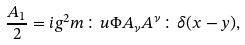<formula> <loc_0><loc_0><loc_500><loc_500>\frac { A _ { 1 } } { 2 } = i g ^ { 2 } m \colon u \Phi A _ { \nu } A ^ { \nu } \colon \delta ( x - y ) ,</formula> 